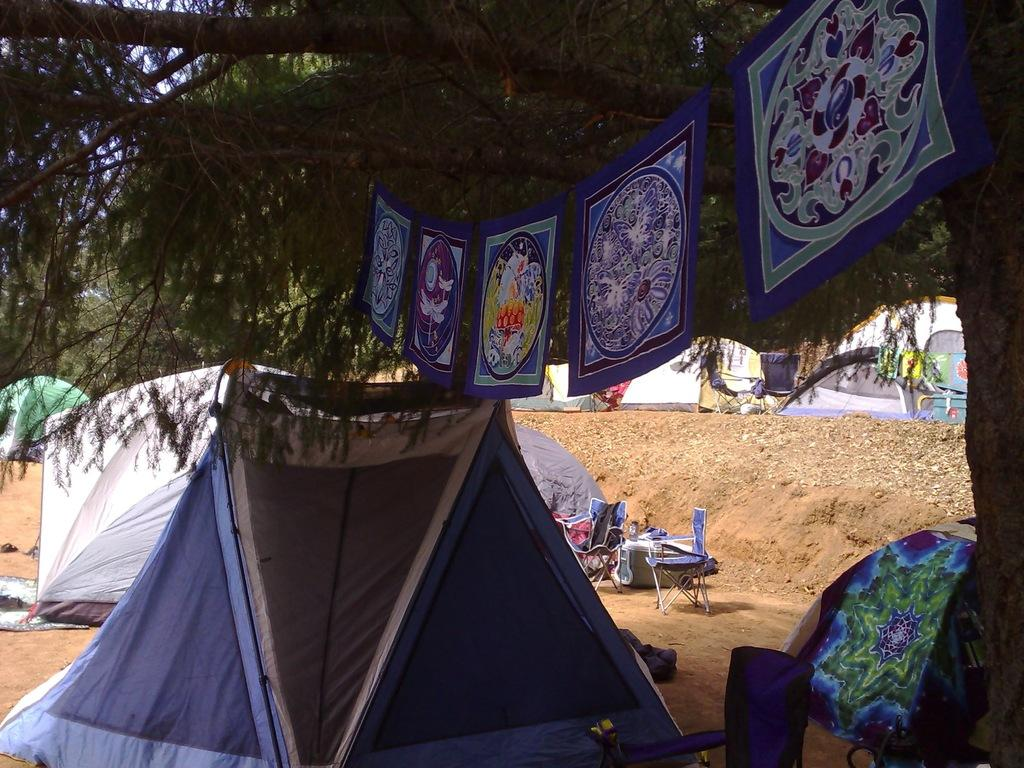What type of temporary shelters can be seen in the image? There are many tents on the mud land in the image. What is located on the right side of the image? There is a tree with a hanger on the right side of the image. What is hanging on the tree? Some clothes are hanging on the tree. What type of furniture can be seen in the middle of the image? There are chairs in the middle of the image. Where are the chairs located? The chairs are on the land. How many clovers are growing on the mud land in the image? There is no mention of clovers in the image; it features tents, a tree, clothes, and chairs. What is the aftermath of the event in the image? The image does not depict an event or its aftermath; it shows a campsite with tents, a tree, clothes, chairs, and mud land. 